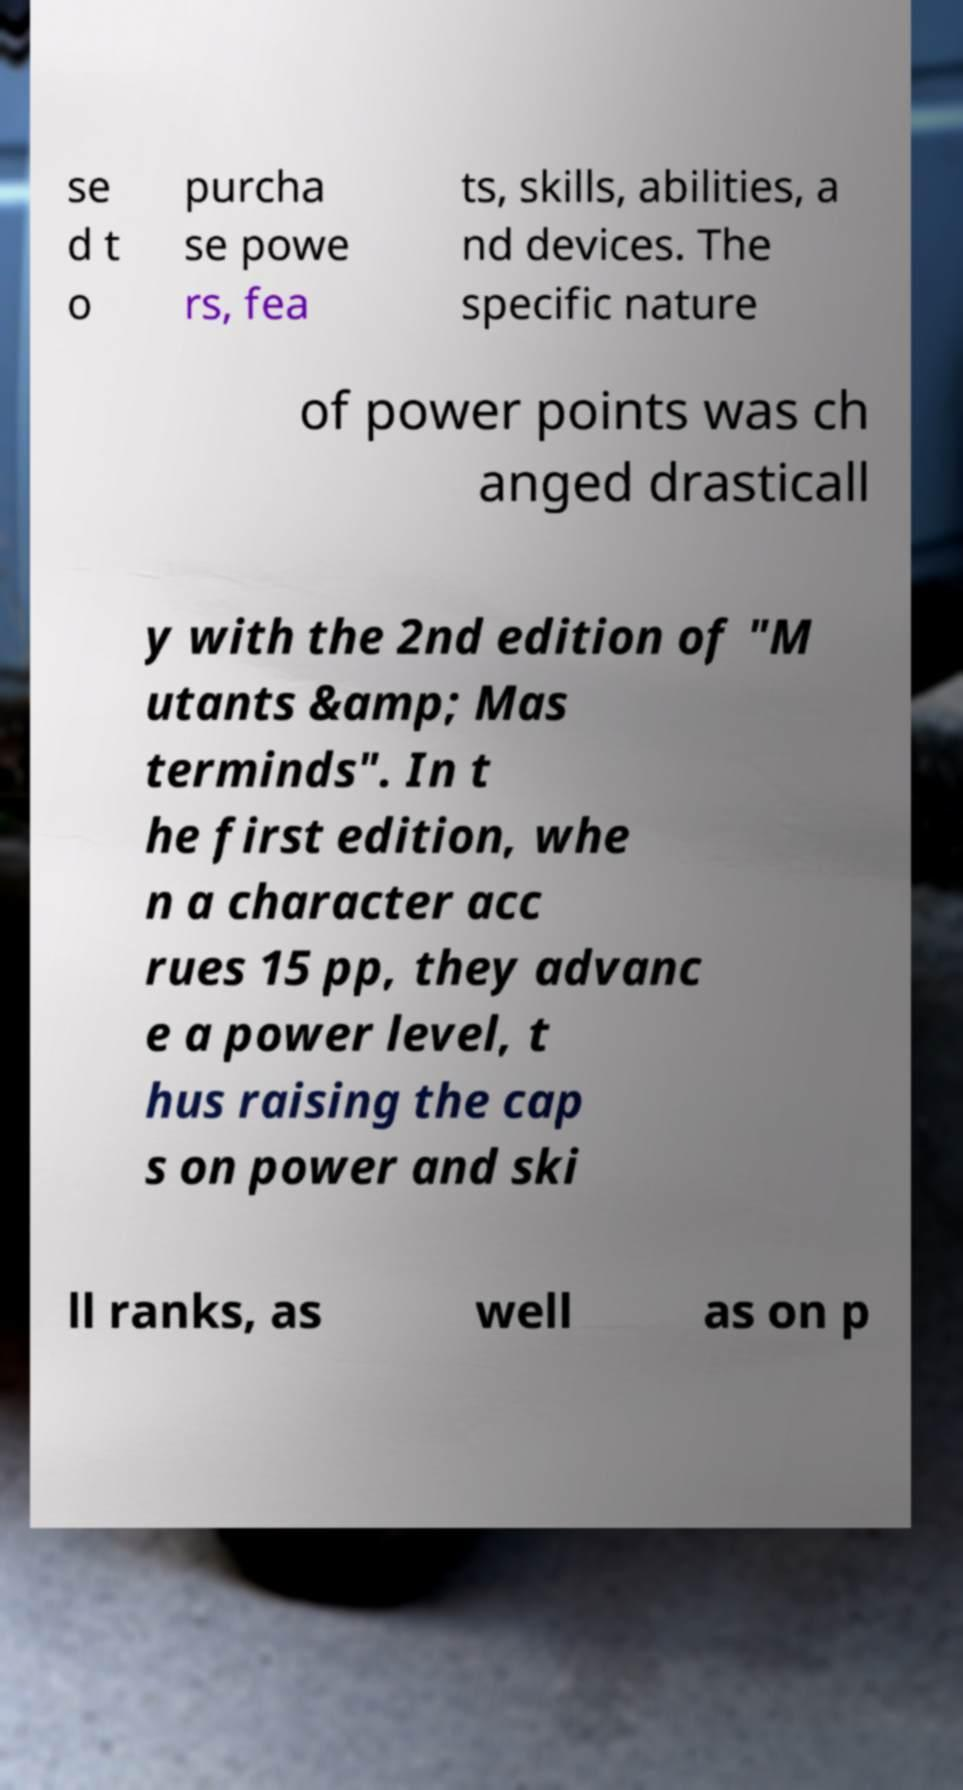There's text embedded in this image that I need extracted. Can you transcribe it verbatim? se d t o purcha se powe rs, fea ts, skills, abilities, a nd devices. The specific nature of power points was ch anged drasticall y with the 2nd edition of "M utants &amp; Mas terminds". In t he first edition, whe n a character acc rues 15 pp, they advanc e a power level, t hus raising the cap s on power and ski ll ranks, as well as on p 